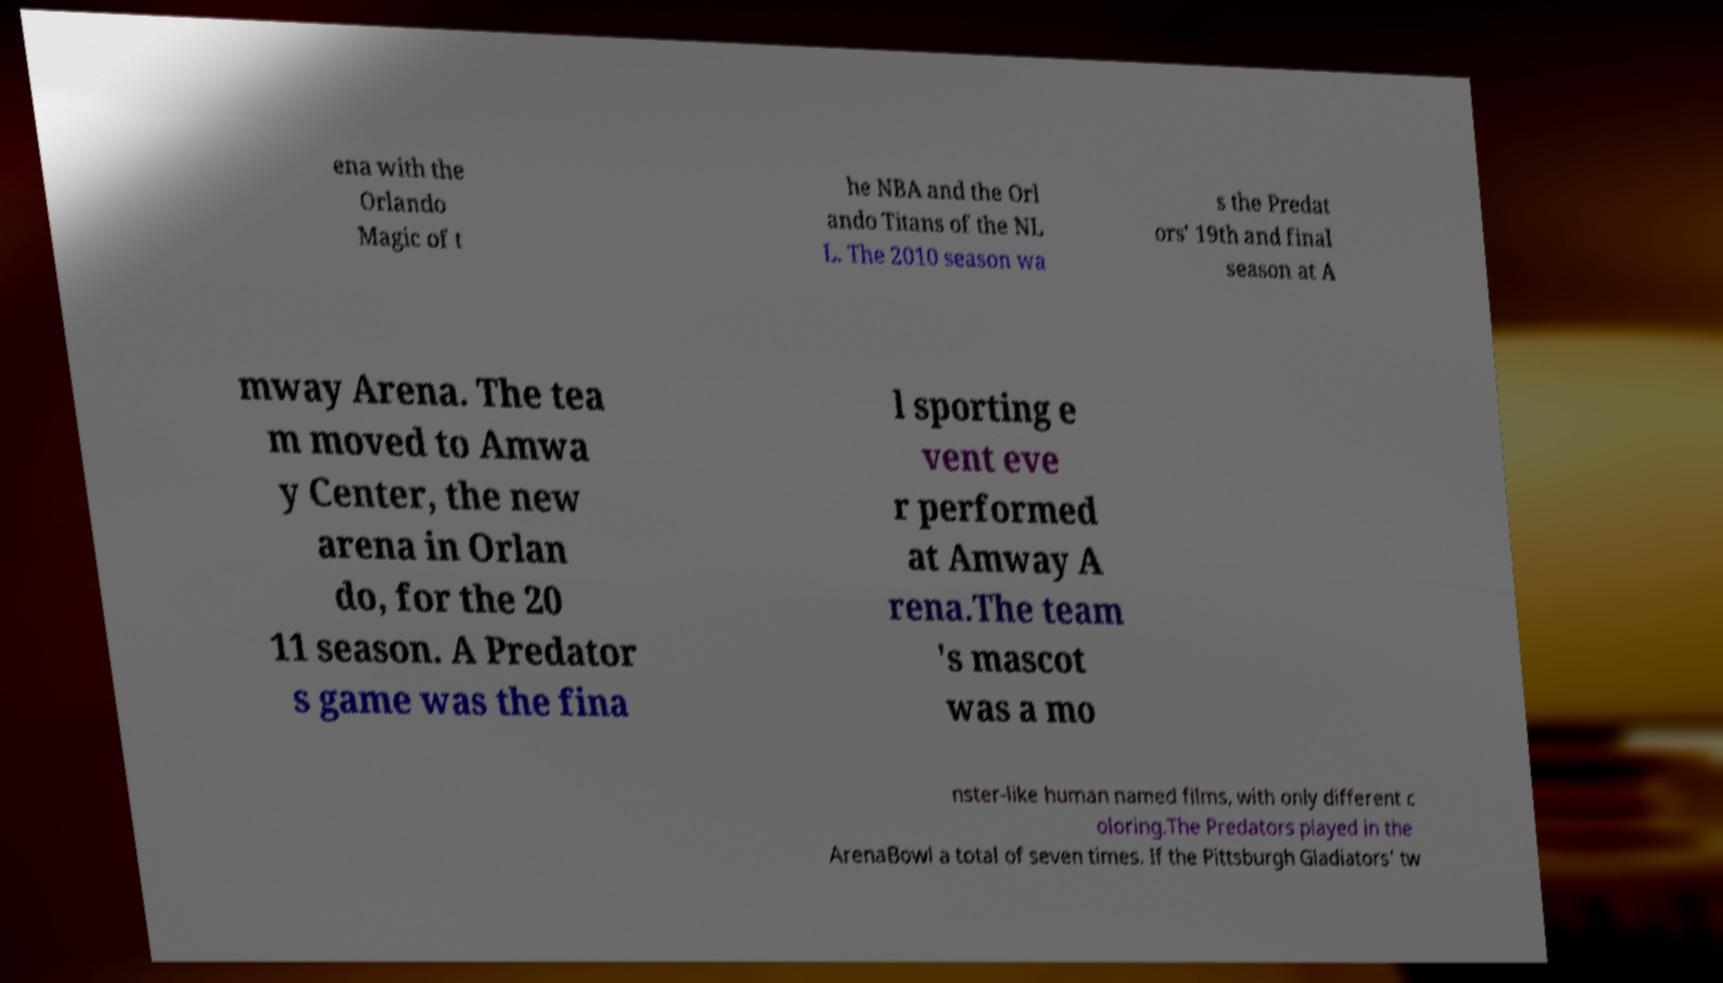Can you read and provide the text displayed in the image?This photo seems to have some interesting text. Can you extract and type it out for me? ena with the Orlando Magic of t he NBA and the Orl ando Titans of the NL L. The 2010 season wa s the Predat ors' 19th and final season at A mway Arena. The tea m moved to Amwa y Center, the new arena in Orlan do, for the 20 11 season. A Predator s game was the fina l sporting e vent eve r performed at Amway A rena.The team 's mascot was a mo nster-like human named films, with only different c oloring.The Predators played in the ArenaBowl a total of seven times. If the Pittsburgh Gladiators' tw 